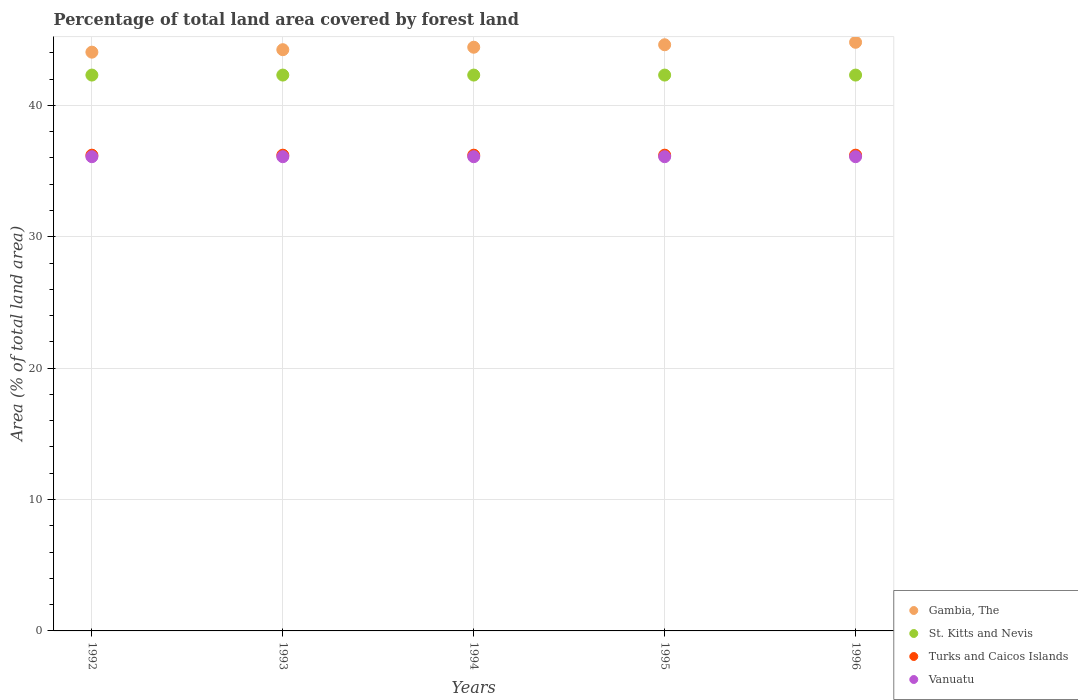How many different coloured dotlines are there?
Your answer should be compact. 4. Is the number of dotlines equal to the number of legend labels?
Keep it short and to the point. Yes. What is the percentage of forest land in Gambia, The in 1995?
Give a very brief answer. 44.61. Across all years, what is the maximum percentage of forest land in St. Kitts and Nevis?
Your answer should be very brief. 42.31. Across all years, what is the minimum percentage of forest land in Vanuatu?
Offer a very short reply. 36.1. In which year was the percentage of forest land in Gambia, The minimum?
Your response must be concise. 1992. What is the total percentage of forest land in St. Kitts and Nevis in the graph?
Your answer should be very brief. 211.54. What is the difference between the percentage of forest land in Vanuatu in 1992 and the percentage of forest land in Gambia, The in 1994?
Provide a succinct answer. -8.33. What is the average percentage of forest land in St. Kitts and Nevis per year?
Your answer should be very brief. 42.31. In the year 1992, what is the difference between the percentage of forest land in Turks and Caicos Islands and percentage of forest land in Vanuatu?
Your response must be concise. 0.12. In how many years, is the percentage of forest land in Turks and Caicos Islands greater than 38 %?
Offer a terse response. 0. Is the percentage of forest land in Vanuatu in 1993 less than that in 1994?
Offer a very short reply. No. Is the difference between the percentage of forest land in Turks and Caicos Islands in 1993 and 1994 greater than the difference between the percentage of forest land in Vanuatu in 1993 and 1994?
Offer a terse response. No. What is the difference between the highest and the lowest percentage of forest land in Vanuatu?
Offer a terse response. 0. Is the sum of the percentage of forest land in Gambia, The in 1992 and 1995 greater than the maximum percentage of forest land in Turks and Caicos Islands across all years?
Offer a very short reply. Yes. Is it the case that in every year, the sum of the percentage of forest land in Gambia, The and percentage of forest land in St. Kitts and Nevis  is greater than the percentage of forest land in Turks and Caicos Islands?
Ensure brevity in your answer.  Yes. Does the graph contain grids?
Offer a very short reply. Yes. Where does the legend appear in the graph?
Provide a succinct answer. Bottom right. How many legend labels are there?
Provide a short and direct response. 4. How are the legend labels stacked?
Offer a very short reply. Vertical. What is the title of the graph?
Ensure brevity in your answer.  Percentage of total land area covered by forest land. What is the label or title of the X-axis?
Your response must be concise. Years. What is the label or title of the Y-axis?
Give a very brief answer. Area (% of total land area). What is the Area (% of total land area) of Gambia, The in 1992?
Ensure brevity in your answer.  44.05. What is the Area (% of total land area) of St. Kitts and Nevis in 1992?
Give a very brief answer. 42.31. What is the Area (% of total land area) in Turks and Caicos Islands in 1992?
Offer a very short reply. 36.21. What is the Area (% of total land area) of Vanuatu in 1992?
Offer a very short reply. 36.1. What is the Area (% of total land area) of Gambia, The in 1993?
Your answer should be compact. 44.24. What is the Area (% of total land area) of St. Kitts and Nevis in 1993?
Offer a terse response. 42.31. What is the Area (% of total land area) of Turks and Caicos Islands in 1993?
Offer a terse response. 36.21. What is the Area (% of total land area) of Vanuatu in 1993?
Your response must be concise. 36.1. What is the Area (% of total land area) in Gambia, The in 1994?
Ensure brevity in your answer.  44.43. What is the Area (% of total land area) of St. Kitts and Nevis in 1994?
Keep it short and to the point. 42.31. What is the Area (% of total land area) of Turks and Caicos Islands in 1994?
Keep it short and to the point. 36.21. What is the Area (% of total land area) of Vanuatu in 1994?
Give a very brief answer. 36.1. What is the Area (% of total land area) of Gambia, The in 1995?
Offer a very short reply. 44.61. What is the Area (% of total land area) in St. Kitts and Nevis in 1995?
Ensure brevity in your answer.  42.31. What is the Area (% of total land area) in Turks and Caicos Islands in 1995?
Make the answer very short. 36.21. What is the Area (% of total land area) of Vanuatu in 1995?
Offer a terse response. 36.1. What is the Area (% of total land area) in Gambia, The in 1996?
Offer a terse response. 44.8. What is the Area (% of total land area) of St. Kitts and Nevis in 1996?
Give a very brief answer. 42.31. What is the Area (% of total land area) in Turks and Caicos Islands in 1996?
Your answer should be very brief. 36.21. What is the Area (% of total land area) of Vanuatu in 1996?
Make the answer very short. 36.1. Across all years, what is the maximum Area (% of total land area) in Gambia, The?
Keep it short and to the point. 44.8. Across all years, what is the maximum Area (% of total land area) in St. Kitts and Nevis?
Your response must be concise. 42.31. Across all years, what is the maximum Area (% of total land area) in Turks and Caicos Islands?
Offer a very short reply. 36.21. Across all years, what is the maximum Area (% of total land area) of Vanuatu?
Provide a short and direct response. 36.1. Across all years, what is the minimum Area (% of total land area) in Gambia, The?
Make the answer very short. 44.05. Across all years, what is the minimum Area (% of total land area) of St. Kitts and Nevis?
Offer a terse response. 42.31. Across all years, what is the minimum Area (% of total land area) in Turks and Caicos Islands?
Give a very brief answer. 36.21. Across all years, what is the minimum Area (% of total land area) in Vanuatu?
Make the answer very short. 36.1. What is the total Area (% of total land area) in Gambia, The in the graph?
Your answer should be compact. 222.13. What is the total Area (% of total land area) of St. Kitts and Nevis in the graph?
Your answer should be very brief. 211.54. What is the total Area (% of total land area) of Turks and Caicos Islands in the graph?
Your answer should be very brief. 181.05. What is the total Area (% of total land area) of Vanuatu in the graph?
Provide a succinct answer. 180.48. What is the difference between the Area (% of total land area) in Gambia, The in 1992 and that in 1993?
Ensure brevity in your answer.  -0.19. What is the difference between the Area (% of total land area) of St. Kitts and Nevis in 1992 and that in 1993?
Provide a succinct answer. 0. What is the difference between the Area (% of total land area) of Turks and Caicos Islands in 1992 and that in 1993?
Offer a very short reply. 0. What is the difference between the Area (% of total land area) of Vanuatu in 1992 and that in 1993?
Give a very brief answer. 0. What is the difference between the Area (% of total land area) in Gambia, The in 1992 and that in 1994?
Make the answer very short. -0.38. What is the difference between the Area (% of total land area) in Gambia, The in 1992 and that in 1995?
Ensure brevity in your answer.  -0.56. What is the difference between the Area (% of total land area) of Vanuatu in 1992 and that in 1995?
Make the answer very short. 0. What is the difference between the Area (% of total land area) in Gambia, The in 1992 and that in 1996?
Keep it short and to the point. -0.75. What is the difference between the Area (% of total land area) of St. Kitts and Nevis in 1992 and that in 1996?
Offer a terse response. 0. What is the difference between the Area (% of total land area) in Turks and Caicos Islands in 1992 and that in 1996?
Your answer should be compact. 0. What is the difference between the Area (% of total land area) in Gambia, The in 1993 and that in 1994?
Your response must be concise. -0.19. What is the difference between the Area (% of total land area) in St. Kitts and Nevis in 1993 and that in 1994?
Your answer should be compact. 0. What is the difference between the Area (% of total land area) of Vanuatu in 1993 and that in 1994?
Provide a succinct answer. 0. What is the difference between the Area (% of total land area) of Gambia, The in 1993 and that in 1995?
Keep it short and to the point. -0.38. What is the difference between the Area (% of total land area) of St. Kitts and Nevis in 1993 and that in 1995?
Make the answer very short. 0. What is the difference between the Area (% of total land area) of Turks and Caicos Islands in 1993 and that in 1995?
Your answer should be compact. 0. What is the difference between the Area (% of total land area) of Vanuatu in 1993 and that in 1995?
Your answer should be compact. 0. What is the difference between the Area (% of total land area) in Gambia, The in 1993 and that in 1996?
Make the answer very short. -0.56. What is the difference between the Area (% of total land area) of St. Kitts and Nevis in 1993 and that in 1996?
Provide a succinct answer. 0. What is the difference between the Area (% of total land area) of Turks and Caicos Islands in 1993 and that in 1996?
Make the answer very short. 0. What is the difference between the Area (% of total land area) in Vanuatu in 1993 and that in 1996?
Keep it short and to the point. 0. What is the difference between the Area (% of total land area) in Gambia, The in 1994 and that in 1995?
Make the answer very short. -0.19. What is the difference between the Area (% of total land area) in St. Kitts and Nevis in 1994 and that in 1995?
Your answer should be compact. 0. What is the difference between the Area (% of total land area) in Gambia, The in 1994 and that in 1996?
Make the answer very short. -0.38. What is the difference between the Area (% of total land area) in St. Kitts and Nevis in 1994 and that in 1996?
Ensure brevity in your answer.  0. What is the difference between the Area (% of total land area) in Turks and Caicos Islands in 1994 and that in 1996?
Your answer should be very brief. 0. What is the difference between the Area (% of total land area) in Vanuatu in 1994 and that in 1996?
Provide a succinct answer. 0. What is the difference between the Area (% of total land area) of Gambia, The in 1995 and that in 1996?
Provide a short and direct response. -0.19. What is the difference between the Area (% of total land area) of St. Kitts and Nevis in 1995 and that in 1996?
Ensure brevity in your answer.  0. What is the difference between the Area (% of total land area) in Turks and Caicos Islands in 1995 and that in 1996?
Make the answer very short. 0. What is the difference between the Area (% of total land area) in Gambia, The in 1992 and the Area (% of total land area) in St. Kitts and Nevis in 1993?
Provide a succinct answer. 1.74. What is the difference between the Area (% of total land area) of Gambia, The in 1992 and the Area (% of total land area) of Turks and Caicos Islands in 1993?
Ensure brevity in your answer.  7.84. What is the difference between the Area (% of total land area) in Gambia, The in 1992 and the Area (% of total land area) in Vanuatu in 1993?
Provide a succinct answer. 7.96. What is the difference between the Area (% of total land area) in St. Kitts and Nevis in 1992 and the Area (% of total land area) in Turks and Caicos Islands in 1993?
Offer a very short reply. 6.1. What is the difference between the Area (% of total land area) of St. Kitts and Nevis in 1992 and the Area (% of total land area) of Vanuatu in 1993?
Your answer should be compact. 6.21. What is the difference between the Area (% of total land area) in Turks and Caicos Islands in 1992 and the Area (% of total land area) in Vanuatu in 1993?
Your answer should be compact. 0.12. What is the difference between the Area (% of total land area) in Gambia, The in 1992 and the Area (% of total land area) in St. Kitts and Nevis in 1994?
Your answer should be compact. 1.74. What is the difference between the Area (% of total land area) in Gambia, The in 1992 and the Area (% of total land area) in Turks and Caicos Islands in 1994?
Provide a short and direct response. 7.84. What is the difference between the Area (% of total land area) in Gambia, The in 1992 and the Area (% of total land area) in Vanuatu in 1994?
Provide a short and direct response. 7.96. What is the difference between the Area (% of total land area) of St. Kitts and Nevis in 1992 and the Area (% of total land area) of Turks and Caicos Islands in 1994?
Provide a succinct answer. 6.1. What is the difference between the Area (% of total land area) in St. Kitts and Nevis in 1992 and the Area (% of total land area) in Vanuatu in 1994?
Your response must be concise. 6.21. What is the difference between the Area (% of total land area) in Turks and Caicos Islands in 1992 and the Area (% of total land area) in Vanuatu in 1994?
Make the answer very short. 0.12. What is the difference between the Area (% of total land area) in Gambia, The in 1992 and the Area (% of total land area) in St. Kitts and Nevis in 1995?
Make the answer very short. 1.74. What is the difference between the Area (% of total land area) in Gambia, The in 1992 and the Area (% of total land area) in Turks and Caicos Islands in 1995?
Offer a very short reply. 7.84. What is the difference between the Area (% of total land area) of Gambia, The in 1992 and the Area (% of total land area) of Vanuatu in 1995?
Your response must be concise. 7.96. What is the difference between the Area (% of total land area) in St. Kitts and Nevis in 1992 and the Area (% of total land area) in Turks and Caicos Islands in 1995?
Your answer should be compact. 6.1. What is the difference between the Area (% of total land area) in St. Kitts and Nevis in 1992 and the Area (% of total land area) in Vanuatu in 1995?
Your answer should be compact. 6.21. What is the difference between the Area (% of total land area) in Turks and Caicos Islands in 1992 and the Area (% of total land area) in Vanuatu in 1995?
Your response must be concise. 0.12. What is the difference between the Area (% of total land area) in Gambia, The in 1992 and the Area (% of total land area) in St. Kitts and Nevis in 1996?
Make the answer very short. 1.74. What is the difference between the Area (% of total land area) in Gambia, The in 1992 and the Area (% of total land area) in Turks and Caicos Islands in 1996?
Your answer should be very brief. 7.84. What is the difference between the Area (% of total land area) of Gambia, The in 1992 and the Area (% of total land area) of Vanuatu in 1996?
Ensure brevity in your answer.  7.96. What is the difference between the Area (% of total land area) of St. Kitts and Nevis in 1992 and the Area (% of total land area) of Turks and Caicos Islands in 1996?
Offer a terse response. 6.1. What is the difference between the Area (% of total land area) of St. Kitts and Nevis in 1992 and the Area (% of total land area) of Vanuatu in 1996?
Ensure brevity in your answer.  6.21. What is the difference between the Area (% of total land area) of Turks and Caicos Islands in 1992 and the Area (% of total land area) of Vanuatu in 1996?
Ensure brevity in your answer.  0.12. What is the difference between the Area (% of total land area) in Gambia, The in 1993 and the Area (% of total land area) in St. Kitts and Nevis in 1994?
Provide a short and direct response. 1.93. What is the difference between the Area (% of total land area) in Gambia, The in 1993 and the Area (% of total land area) in Turks and Caicos Islands in 1994?
Your answer should be compact. 8.03. What is the difference between the Area (% of total land area) of Gambia, The in 1993 and the Area (% of total land area) of Vanuatu in 1994?
Provide a short and direct response. 8.14. What is the difference between the Area (% of total land area) in St. Kitts and Nevis in 1993 and the Area (% of total land area) in Turks and Caicos Islands in 1994?
Provide a succinct answer. 6.1. What is the difference between the Area (% of total land area) of St. Kitts and Nevis in 1993 and the Area (% of total land area) of Vanuatu in 1994?
Give a very brief answer. 6.21. What is the difference between the Area (% of total land area) in Turks and Caicos Islands in 1993 and the Area (% of total land area) in Vanuatu in 1994?
Your response must be concise. 0.12. What is the difference between the Area (% of total land area) in Gambia, The in 1993 and the Area (% of total land area) in St. Kitts and Nevis in 1995?
Provide a short and direct response. 1.93. What is the difference between the Area (% of total land area) in Gambia, The in 1993 and the Area (% of total land area) in Turks and Caicos Islands in 1995?
Your answer should be compact. 8.03. What is the difference between the Area (% of total land area) of Gambia, The in 1993 and the Area (% of total land area) of Vanuatu in 1995?
Offer a terse response. 8.14. What is the difference between the Area (% of total land area) of St. Kitts and Nevis in 1993 and the Area (% of total land area) of Turks and Caicos Islands in 1995?
Keep it short and to the point. 6.1. What is the difference between the Area (% of total land area) in St. Kitts and Nevis in 1993 and the Area (% of total land area) in Vanuatu in 1995?
Keep it short and to the point. 6.21. What is the difference between the Area (% of total land area) of Turks and Caicos Islands in 1993 and the Area (% of total land area) of Vanuatu in 1995?
Your answer should be very brief. 0.12. What is the difference between the Area (% of total land area) of Gambia, The in 1993 and the Area (% of total land area) of St. Kitts and Nevis in 1996?
Provide a short and direct response. 1.93. What is the difference between the Area (% of total land area) of Gambia, The in 1993 and the Area (% of total land area) of Turks and Caicos Islands in 1996?
Ensure brevity in your answer.  8.03. What is the difference between the Area (% of total land area) of Gambia, The in 1993 and the Area (% of total land area) of Vanuatu in 1996?
Provide a succinct answer. 8.14. What is the difference between the Area (% of total land area) in St. Kitts and Nevis in 1993 and the Area (% of total land area) in Turks and Caicos Islands in 1996?
Provide a succinct answer. 6.1. What is the difference between the Area (% of total land area) of St. Kitts and Nevis in 1993 and the Area (% of total land area) of Vanuatu in 1996?
Your answer should be very brief. 6.21. What is the difference between the Area (% of total land area) of Turks and Caicos Islands in 1993 and the Area (% of total land area) of Vanuatu in 1996?
Offer a terse response. 0.12. What is the difference between the Area (% of total land area) of Gambia, The in 1994 and the Area (% of total land area) of St. Kitts and Nevis in 1995?
Provide a succinct answer. 2.12. What is the difference between the Area (% of total land area) of Gambia, The in 1994 and the Area (% of total land area) of Turks and Caicos Islands in 1995?
Provide a short and direct response. 8.22. What is the difference between the Area (% of total land area) of Gambia, The in 1994 and the Area (% of total land area) of Vanuatu in 1995?
Provide a short and direct response. 8.33. What is the difference between the Area (% of total land area) of St. Kitts and Nevis in 1994 and the Area (% of total land area) of Turks and Caicos Islands in 1995?
Make the answer very short. 6.1. What is the difference between the Area (% of total land area) of St. Kitts and Nevis in 1994 and the Area (% of total land area) of Vanuatu in 1995?
Give a very brief answer. 6.21. What is the difference between the Area (% of total land area) of Turks and Caicos Islands in 1994 and the Area (% of total land area) of Vanuatu in 1995?
Offer a very short reply. 0.12. What is the difference between the Area (% of total land area) in Gambia, The in 1994 and the Area (% of total land area) in St. Kitts and Nevis in 1996?
Provide a short and direct response. 2.12. What is the difference between the Area (% of total land area) in Gambia, The in 1994 and the Area (% of total land area) in Turks and Caicos Islands in 1996?
Your response must be concise. 8.22. What is the difference between the Area (% of total land area) of Gambia, The in 1994 and the Area (% of total land area) of Vanuatu in 1996?
Offer a terse response. 8.33. What is the difference between the Area (% of total land area) in St. Kitts and Nevis in 1994 and the Area (% of total land area) in Turks and Caicos Islands in 1996?
Provide a short and direct response. 6.1. What is the difference between the Area (% of total land area) of St. Kitts and Nevis in 1994 and the Area (% of total land area) of Vanuatu in 1996?
Your answer should be very brief. 6.21. What is the difference between the Area (% of total land area) of Turks and Caicos Islands in 1994 and the Area (% of total land area) of Vanuatu in 1996?
Provide a short and direct response. 0.12. What is the difference between the Area (% of total land area) in Gambia, The in 1995 and the Area (% of total land area) in St. Kitts and Nevis in 1996?
Keep it short and to the point. 2.31. What is the difference between the Area (% of total land area) in Gambia, The in 1995 and the Area (% of total land area) in Turks and Caicos Islands in 1996?
Provide a succinct answer. 8.4. What is the difference between the Area (% of total land area) in Gambia, The in 1995 and the Area (% of total land area) in Vanuatu in 1996?
Keep it short and to the point. 8.52. What is the difference between the Area (% of total land area) in St. Kitts and Nevis in 1995 and the Area (% of total land area) in Turks and Caicos Islands in 1996?
Give a very brief answer. 6.1. What is the difference between the Area (% of total land area) of St. Kitts and Nevis in 1995 and the Area (% of total land area) of Vanuatu in 1996?
Make the answer very short. 6.21. What is the difference between the Area (% of total land area) of Turks and Caicos Islands in 1995 and the Area (% of total land area) of Vanuatu in 1996?
Give a very brief answer. 0.12. What is the average Area (% of total land area) in Gambia, The per year?
Give a very brief answer. 44.43. What is the average Area (% of total land area) of St. Kitts and Nevis per year?
Offer a terse response. 42.31. What is the average Area (% of total land area) of Turks and Caicos Islands per year?
Provide a short and direct response. 36.21. What is the average Area (% of total land area) in Vanuatu per year?
Your answer should be compact. 36.1. In the year 1992, what is the difference between the Area (% of total land area) of Gambia, The and Area (% of total land area) of St. Kitts and Nevis?
Ensure brevity in your answer.  1.74. In the year 1992, what is the difference between the Area (% of total land area) of Gambia, The and Area (% of total land area) of Turks and Caicos Islands?
Make the answer very short. 7.84. In the year 1992, what is the difference between the Area (% of total land area) in Gambia, The and Area (% of total land area) in Vanuatu?
Ensure brevity in your answer.  7.96. In the year 1992, what is the difference between the Area (% of total land area) of St. Kitts and Nevis and Area (% of total land area) of Turks and Caicos Islands?
Your response must be concise. 6.1. In the year 1992, what is the difference between the Area (% of total land area) of St. Kitts and Nevis and Area (% of total land area) of Vanuatu?
Keep it short and to the point. 6.21. In the year 1992, what is the difference between the Area (% of total land area) of Turks and Caicos Islands and Area (% of total land area) of Vanuatu?
Ensure brevity in your answer.  0.12. In the year 1993, what is the difference between the Area (% of total land area) in Gambia, The and Area (% of total land area) in St. Kitts and Nevis?
Your response must be concise. 1.93. In the year 1993, what is the difference between the Area (% of total land area) of Gambia, The and Area (% of total land area) of Turks and Caicos Islands?
Make the answer very short. 8.03. In the year 1993, what is the difference between the Area (% of total land area) in Gambia, The and Area (% of total land area) in Vanuatu?
Provide a short and direct response. 8.14. In the year 1993, what is the difference between the Area (% of total land area) in St. Kitts and Nevis and Area (% of total land area) in Turks and Caicos Islands?
Offer a very short reply. 6.1. In the year 1993, what is the difference between the Area (% of total land area) of St. Kitts and Nevis and Area (% of total land area) of Vanuatu?
Keep it short and to the point. 6.21. In the year 1993, what is the difference between the Area (% of total land area) of Turks and Caicos Islands and Area (% of total land area) of Vanuatu?
Give a very brief answer. 0.12. In the year 1994, what is the difference between the Area (% of total land area) of Gambia, The and Area (% of total land area) of St. Kitts and Nevis?
Keep it short and to the point. 2.12. In the year 1994, what is the difference between the Area (% of total land area) in Gambia, The and Area (% of total land area) in Turks and Caicos Islands?
Your answer should be compact. 8.22. In the year 1994, what is the difference between the Area (% of total land area) of Gambia, The and Area (% of total land area) of Vanuatu?
Give a very brief answer. 8.33. In the year 1994, what is the difference between the Area (% of total land area) of St. Kitts and Nevis and Area (% of total land area) of Turks and Caicos Islands?
Keep it short and to the point. 6.1. In the year 1994, what is the difference between the Area (% of total land area) in St. Kitts and Nevis and Area (% of total land area) in Vanuatu?
Keep it short and to the point. 6.21. In the year 1994, what is the difference between the Area (% of total land area) of Turks and Caicos Islands and Area (% of total land area) of Vanuatu?
Your response must be concise. 0.12. In the year 1995, what is the difference between the Area (% of total land area) in Gambia, The and Area (% of total land area) in St. Kitts and Nevis?
Give a very brief answer. 2.31. In the year 1995, what is the difference between the Area (% of total land area) in Gambia, The and Area (% of total land area) in Turks and Caicos Islands?
Your answer should be compact. 8.4. In the year 1995, what is the difference between the Area (% of total land area) of Gambia, The and Area (% of total land area) of Vanuatu?
Your response must be concise. 8.52. In the year 1995, what is the difference between the Area (% of total land area) in St. Kitts and Nevis and Area (% of total land area) in Turks and Caicos Islands?
Ensure brevity in your answer.  6.1. In the year 1995, what is the difference between the Area (% of total land area) of St. Kitts and Nevis and Area (% of total land area) of Vanuatu?
Your answer should be compact. 6.21. In the year 1995, what is the difference between the Area (% of total land area) in Turks and Caicos Islands and Area (% of total land area) in Vanuatu?
Offer a very short reply. 0.12. In the year 1996, what is the difference between the Area (% of total land area) in Gambia, The and Area (% of total land area) in St. Kitts and Nevis?
Keep it short and to the point. 2.49. In the year 1996, what is the difference between the Area (% of total land area) of Gambia, The and Area (% of total land area) of Turks and Caicos Islands?
Keep it short and to the point. 8.59. In the year 1996, what is the difference between the Area (% of total land area) of Gambia, The and Area (% of total land area) of Vanuatu?
Your answer should be compact. 8.71. In the year 1996, what is the difference between the Area (% of total land area) in St. Kitts and Nevis and Area (% of total land area) in Turks and Caicos Islands?
Offer a very short reply. 6.1. In the year 1996, what is the difference between the Area (% of total land area) of St. Kitts and Nevis and Area (% of total land area) of Vanuatu?
Offer a terse response. 6.21. In the year 1996, what is the difference between the Area (% of total land area) in Turks and Caicos Islands and Area (% of total land area) in Vanuatu?
Offer a terse response. 0.12. What is the ratio of the Area (% of total land area) of Vanuatu in 1992 to that in 1993?
Provide a short and direct response. 1. What is the ratio of the Area (% of total land area) in Gambia, The in 1992 to that in 1994?
Give a very brief answer. 0.99. What is the ratio of the Area (% of total land area) in St. Kitts and Nevis in 1992 to that in 1994?
Your answer should be very brief. 1. What is the ratio of the Area (% of total land area) in Turks and Caicos Islands in 1992 to that in 1994?
Your response must be concise. 1. What is the ratio of the Area (% of total land area) in Gambia, The in 1992 to that in 1995?
Your answer should be very brief. 0.99. What is the ratio of the Area (% of total land area) in Turks and Caicos Islands in 1992 to that in 1995?
Your response must be concise. 1. What is the ratio of the Area (% of total land area) of Vanuatu in 1992 to that in 1995?
Your answer should be very brief. 1. What is the ratio of the Area (% of total land area) of Gambia, The in 1992 to that in 1996?
Your response must be concise. 0.98. What is the ratio of the Area (% of total land area) in Gambia, The in 1993 to that in 1994?
Provide a succinct answer. 1. What is the ratio of the Area (% of total land area) in Turks and Caicos Islands in 1993 to that in 1994?
Your answer should be very brief. 1. What is the ratio of the Area (% of total land area) of Vanuatu in 1993 to that in 1994?
Your answer should be very brief. 1. What is the ratio of the Area (% of total land area) of Gambia, The in 1993 to that in 1995?
Your response must be concise. 0.99. What is the ratio of the Area (% of total land area) of St. Kitts and Nevis in 1993 to that in 1995?
Make the answer very short. 1. What is the ratio of the Area (% of total land area) of Turks and Caicos Islands in 1993 to that in 1995?
Provide a short and direct response. 1. What is the ratio of the Area (% of total land area) of Vanuatu in 1993 to that in 1995?
Give a very brief answer. 1. What is the ratio of the Area (% of total land area) in Gambia, The in 1993 to that in 1996?
Keep it short and to the point. 0.99. What is the ratio of the Area (% of total land area) in St. Kitts and Nevis in 1993 to that in 1996?
Your response must be concise. 1. What is the ratio of the Area (% of total land area) of Turks and Caicos Islands in 1993 to that in 1996?
Ensure brevity in your answer.  1. What is the ratio of the Area (% of total land area) of Vanuatu in 1993 to that in 1996?
Offer a terse response. 1. What is the ratio of the Area (% of total land area) of St. Kitts and Nevis in 1994 to that in 1995?
Your answer should be very brief. 1. What is the ratio of the Area (% of total land area) in Turks and Caicos Islands in 1994 to that in 1995?
Provide a succinct answer. 1. What is the ratio of the Area (% of total land area) in Gambia, The in 1994 to that in 1996?
Give a very brief answer. 0.99. What is the ratio of the Area (% of total land area) of St. Kitts and Nevis in 1994 to that in 1996?
Offer a terse response. 1. What is the ratio of the Area (% of total land area) in Turks and Caicos Islands in 1994 to that in 1996?
Provide a short and direct response. 1. What is the ratio of the Area (% of total land area) of Vanuatu in 1994 to that in 1996?
Give a very brief answer. 1. What is the ratio of the Area (% of total land area) of Gambia, The in 1995 to that in 1996?
Make the answer very short. 1. What is the difference between the highest and the second highest Area (% of total land area) in Gambia, The?
Ensure brevity in your answer.  0.19. What is the difference between the highest and the second highest Area (% of total land area) in Turks and Caicos Islands?
Your answer should be very brief. 0. What is the difference between the highest and the lowest Area (% of total land area) in Gambia, The?
Your response must be concise. 0.75. What is the difference between the highest and the lowest Area (% of total land area) in Turks and Caicos Islands?
Your response must be concise. 0. 